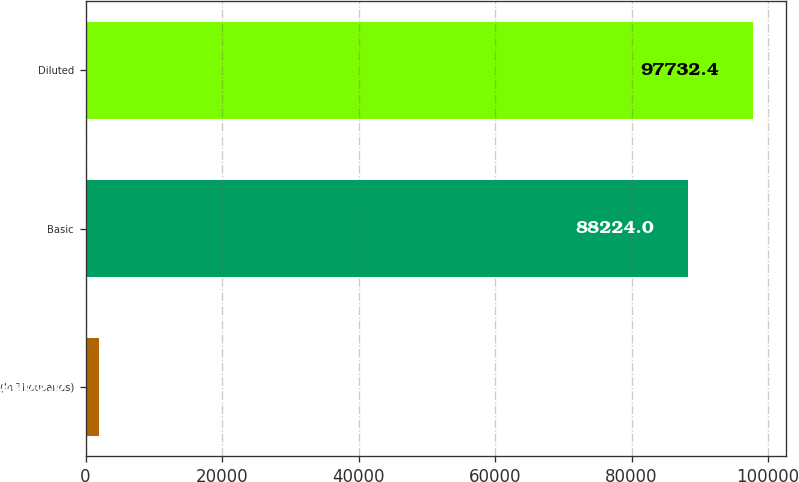Convert chart to OTSL. <chart><loc_0><loc_0><loc_500><loc_500><bar_chart><fcel>(In Thousands)<fcel>Basic<fcel>Diluted<nl><fcel>2005<fcel>88224<fcel>97732.4<nl></chart> 